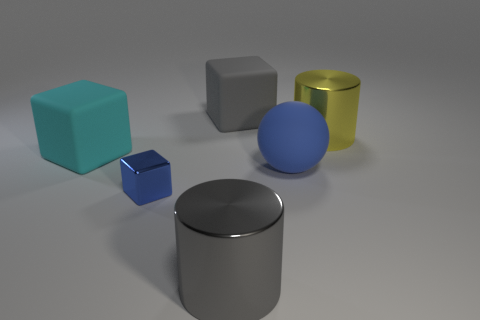Is there any other thing that is the same size as the blue metal object?
Keep it short and to the point. No. How many cyan rubber blocks have the same size as the gray shiny cylinder?
Your answer should be very brief. 1. Are there an equal number of tiny blue metallic cubes behind the big blue object and big brown metal things?
Your answer should be compact. Yes. How many large things are both behind the cyan object and on the right side of the big gray matte thing?
Provide a succinct answer. 1. The cyan object that is made of the same material as the gray block is what size?
Give a very brief answer. Large. How many other cyan objects have the same shape as the cyan matte object?
Keep it short and to the point. 0. Are there more large blue balls in front of the cyan matte cube than large brown metal cubes?
Provide a succinct answer. Yes. The large object that is both behind the tiny block and in front of the cyan object has what shape?
Offer a terse response. Sphere. Is the size of the yellow cylinder the same as the gray shiny object?
Offer a terse response. Yes. There is a yellow shiny object; how many big gray objects are behind it?
Provide a succinct answer. 1. 